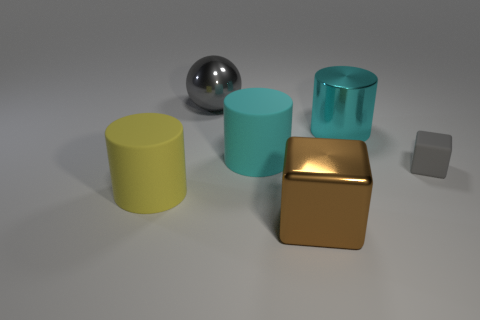Are there any other things that have the same size as the gray block?
Provide a short and direct response. No. Is the material of the brown block the same as the cylinder that is in front of the small gray matte thing?
Give a very brief answer. No. Is there anything else that is the same shape as the gray shiny object?
Your response must be concise. No. What is the color of the object that is left of the big cyan matte object and in front of the gray metal sphere?
Provide a succinct answer. Yellow. There is a rubber object behind the small block; what is its shape?
Your response must be concise. Cylinder. There is a cyan cylinder behind the rubber cylinder right of the thing that is left of the shiny sphere; what size is it?
Offer a terse response. Large. There is a rubber cylinder that is behind the yellow cylinder; what number of matte things are in front of it?
Give a very brief answer. 2. What is the size of the thing that is in front of the cyan metallic cylinder and to the right of the large brown cube?
Provide a short and direct response. Small. What number of shiny objects are brown spheres or gray spheres?
Your answer should be compact. 1. What material is the big yellow thing?
Your answer should be very brief. Rubber. 